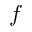Convert formula to latex. <formula><loc_0><loc_0><loc_500><loc_500>f</formula> 